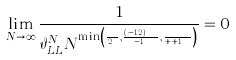Convert formula to latex. <formula><loc_0><loc_0><loc_500><loc_500>\lim _ { N \rightarrow \infty } \frac { 1 } { \vartheta _ { L L } ^ { N } N ^ { \min \left ( \frac { x \gamma } { 2 \tau } , \frac { ( \alpha - 1 / 2 ) x } { x - 1 } , \frac { \beta x } { x + \tau + 1 } \right ) } } = 0</formula> 